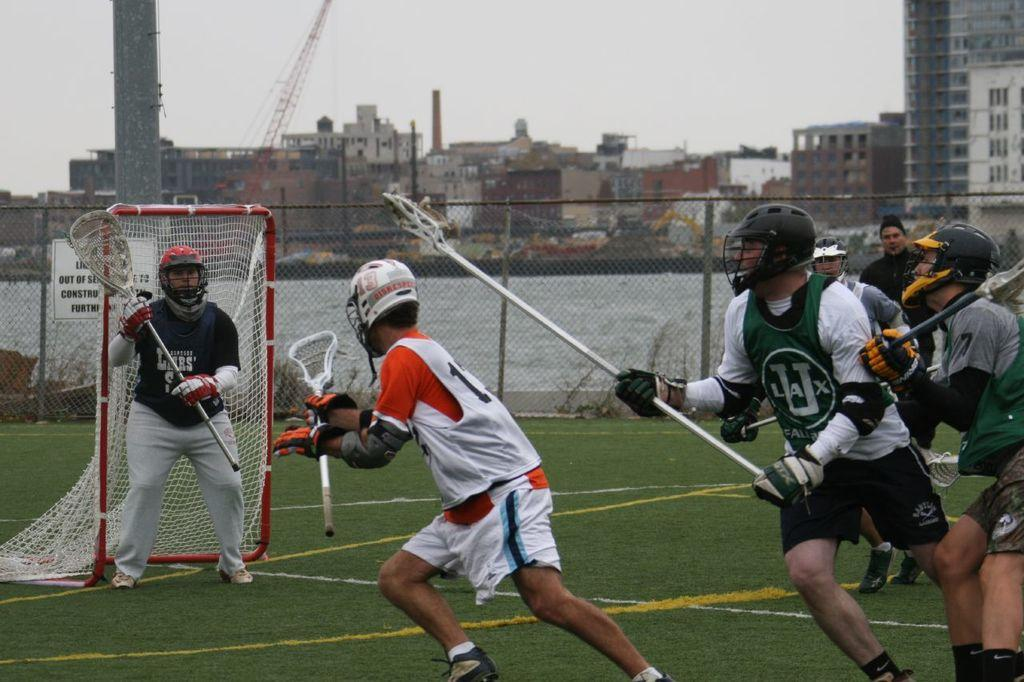<image>
Create a compact narrative representing the image presented. one of the team is wearing green ULAX jersey 